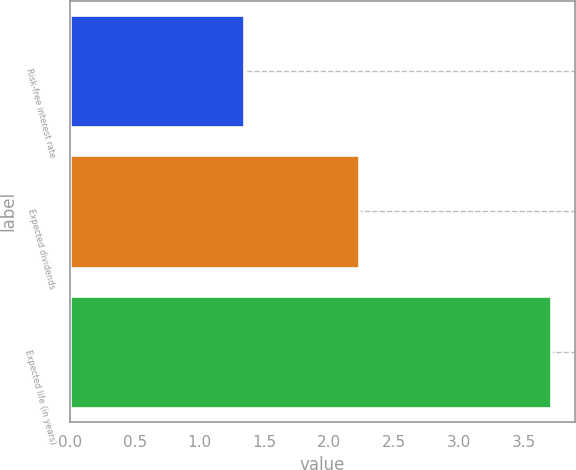<chart> <loc_0><loc_0><loc_500><loc_500><bar_chart><fcel>Risk-free interest rate<fcel>Expected dividends<fcel>Expected life (in years)<nl><fcel>1.34<fcel>2.23<fcel>3.71<nl></chart> 